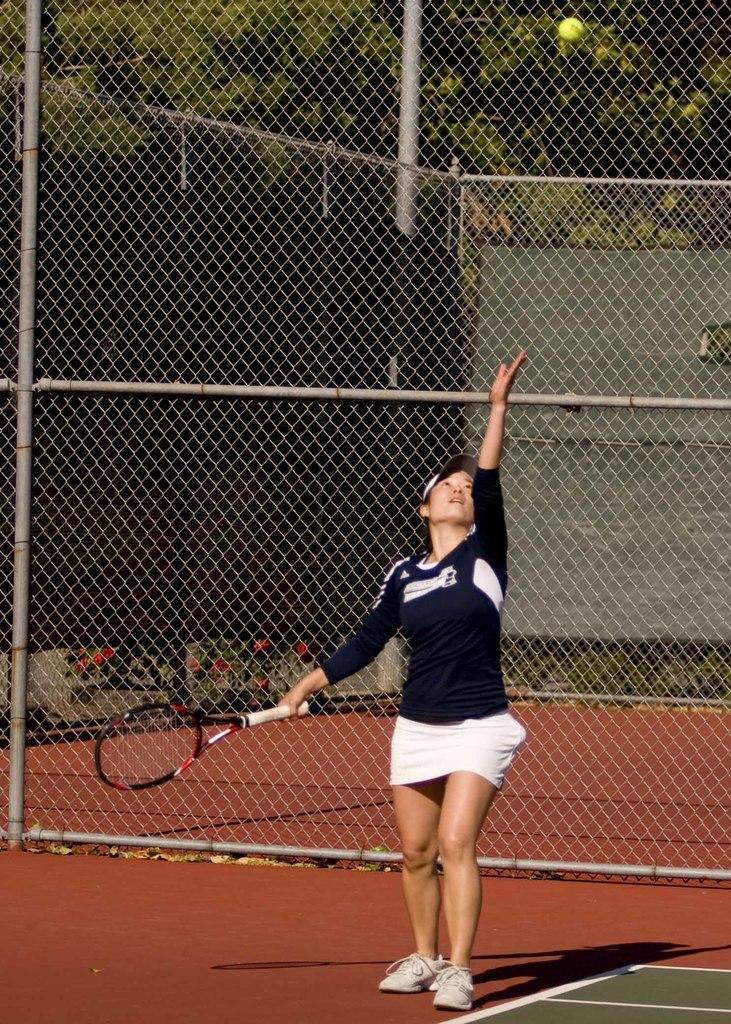Could you give a brief overview of what you see in this image? In this image I can see a woman is standing and she is holding a racket. Here I can see a tennis ball. 